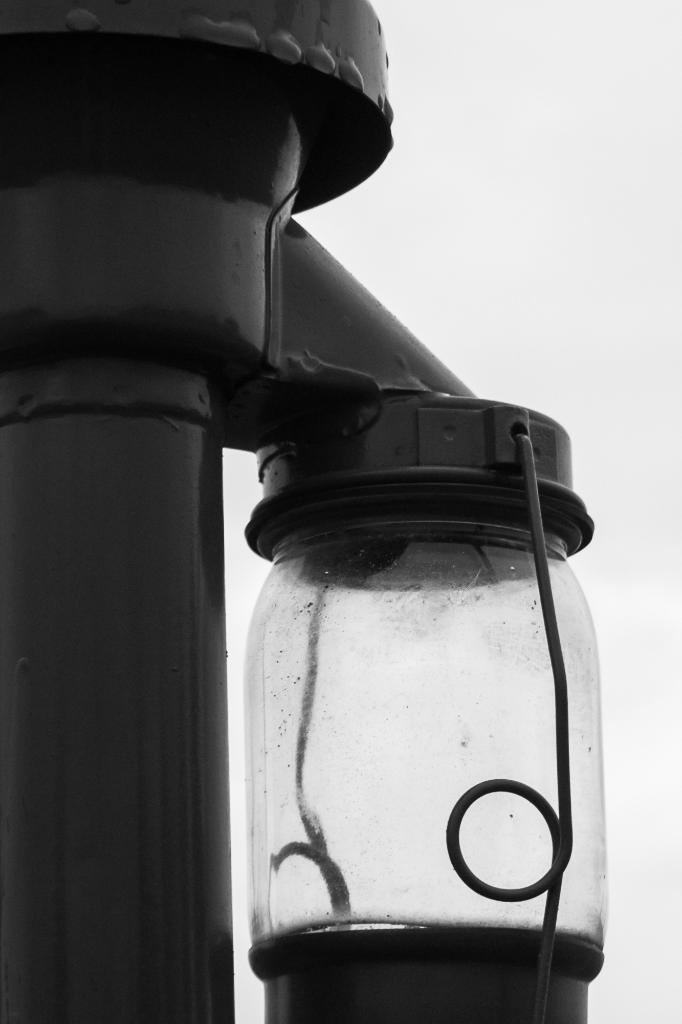What is the color scheme of the image? The image is black and white. What can be seen on the left side of the image? There is a pole on the left side of the image. What is attached to the pole in the image? There is a glass jar attached to the pole. What is the weather like on the moon in the image? There is no moon present in the image, and therefore no weather conditions to describe. How much oil is in the glass jar in the image? There is no indication of the contents of the glass jar in the image, so it cannot be determined if it contains oil or any other substance. 